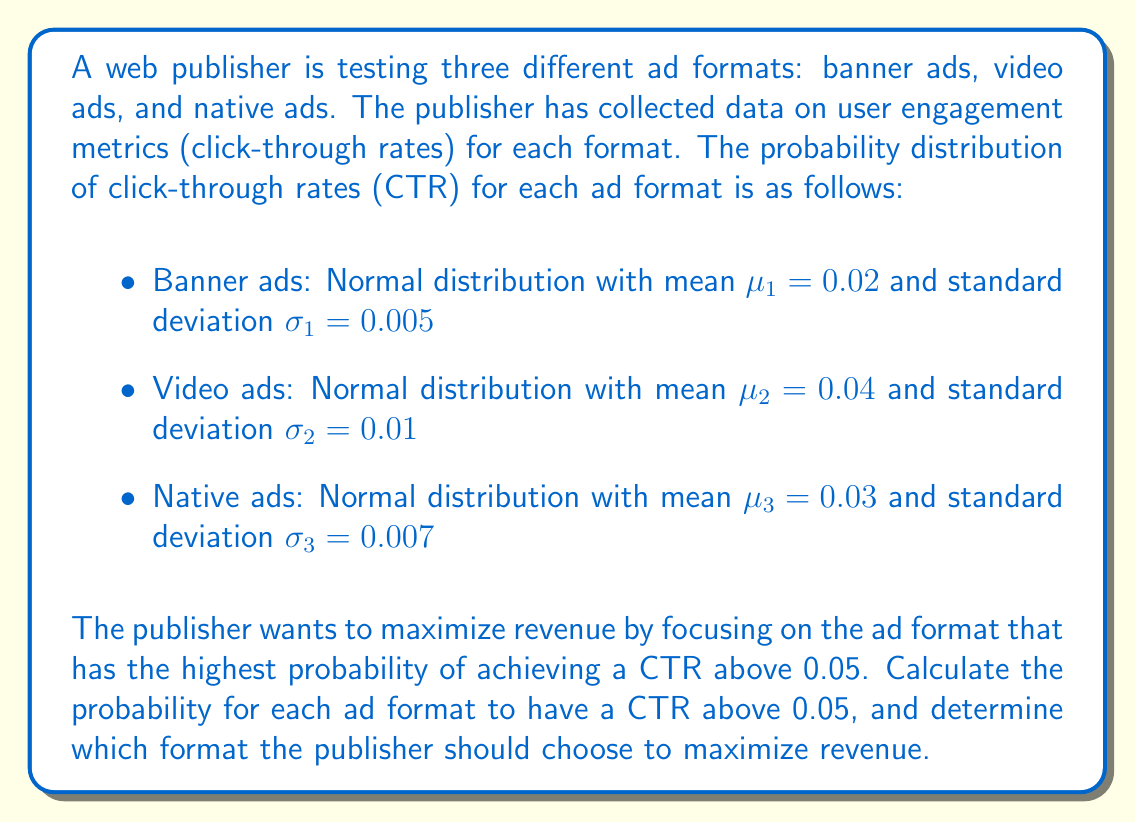Help me with this question. To solve this problem, we need to calculate the probability that the CTR for each ad format exceeds 0.05. We can use the standard normal distribution (z-score) to calculate these probabilities.

For each ad format, we'll follow these steps:
1. Calculate the z-score for CTR = 0.05
2. Use the z-score to find the probability of exceeding 0.05

Step 1: Calculate z-scores

The formula for z-score is: $$z = \frac{x - \mu}{\sigma}$$

Where $x$ is the value we're interested in (0.05), $\mu$ is the mean, and $\sigma$ is the standard deviation.

Banner ads:
$$z_1 = \frac{0.05 - 0.02}{0.005} = 6$$

Video ads:
$$z_2 = \frac{0.05 - 0.04}{0.01} = 1$$

Native ads:
$$z_3 = \frac{0.05 - 0.03}{0.007} \approx 2.857$$

Step 2: Calculate probabilities

We need to find $P(X > 0.05)$ for each ad format, which is equivalent to $P(Z > z)$ where $Z$ is the standard normal variable.

Using a standard normal distribution table or calculator:

Banner ads: $P(Z > 6) \approx 0.0000001$ (essentially zero)
Video ads: $P(Z > 1) \approx 0.1587$
Native ads: $P(Z > 2.857) \approx 0.0021$

Therefore, the probabilities of each ad format having a CTR above 0.05 are:

Banner ads: $\approx 0\%$
Video ads: $\approx 15.87\%$
Native ads: $\approx 0.21\%$
Answer: The video ad format has the highest probability (15.87%) of achieving a CTR above 0.05. Therefore, the publisher should choose video ads to maximize revenue. 